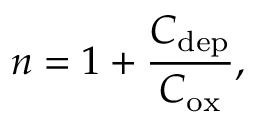<formula> <loc_0><loc_0><loc_500><loc_500>n = 1 + { \frac { C _ { d e p } } { C _ { o x } } } ,</formula> 